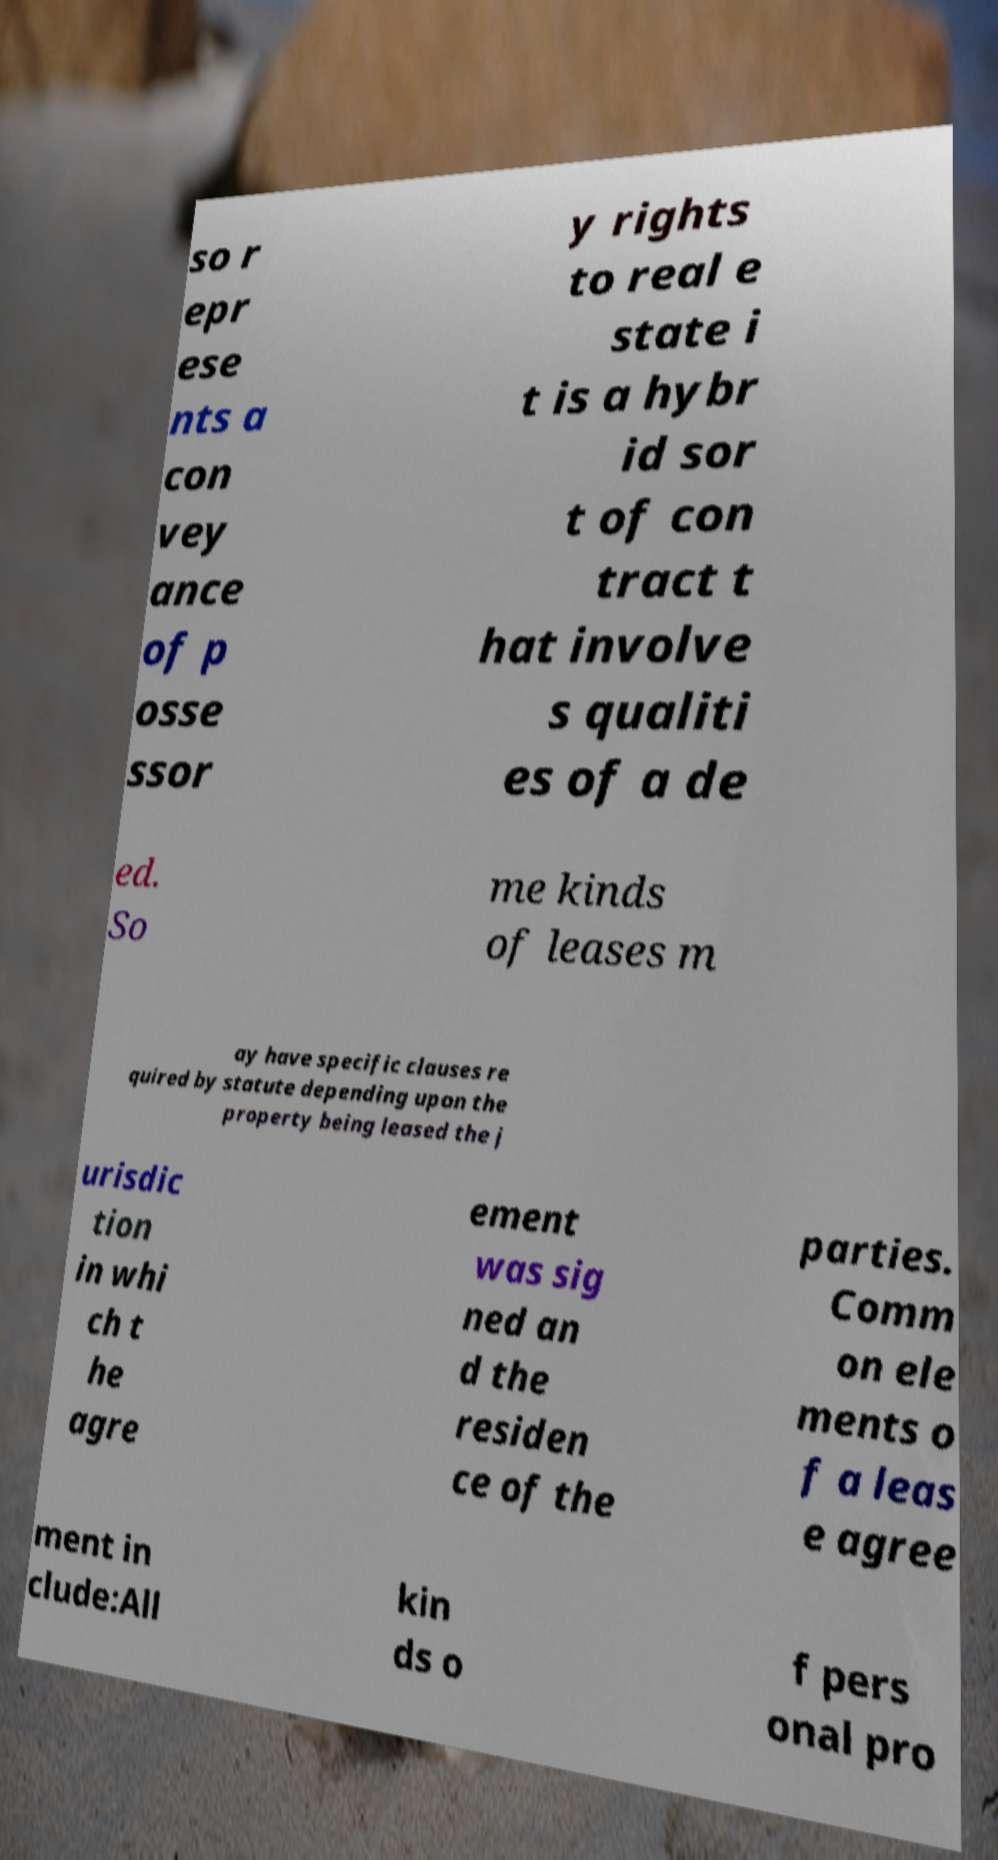Could you assist in decoding the text presented in this image and type it out clearly? so r epr ese nts a con vey ance of p osse ssor y rights to real e state i t is a hybr id sor t of con tract t hat involve s qualiti es of a de ed. So me kinds of leases m ay have specific clauses re quired by statute depending upon the property being leased the j urisdic tion in whi ch t he agre ement was sig ned an d the residen ce of the parties. Comm on ele ments o f a leas e agree ment in clude:All kin ds o f pers onal pro 